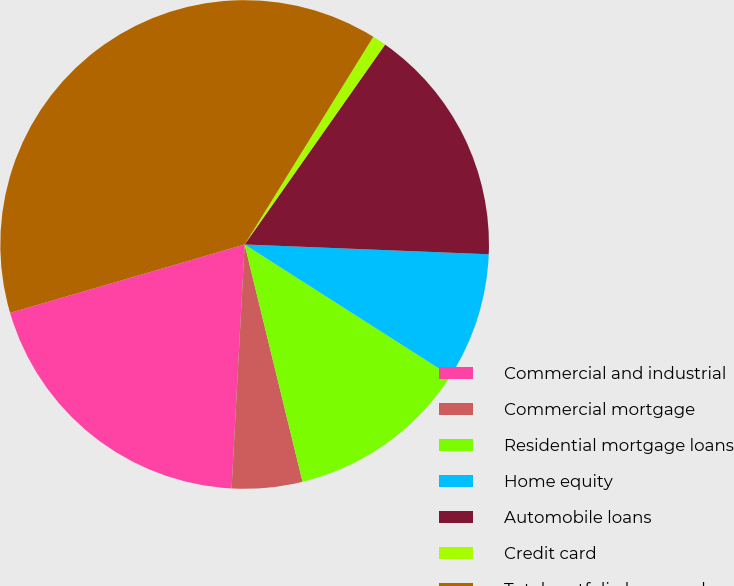Convert chart to OTSL. <chart><loc_0><loc_0><loc_500><loc_500><pie_chart><fcel>Commercial and industrial<fcel>Commercial mortgage<fcel>Residential mortgage loans<fcel>Home equity<fcel>Automobile loans<fcel>Credit card<fcel>Total portfolio loans and<nl><fcel>19.63%<fcel>4.66%<fcel>12.15%<fcel>8.4%<fcel>15.89%<fcel>0.92%<fcel>38.34%<nl></chart> 